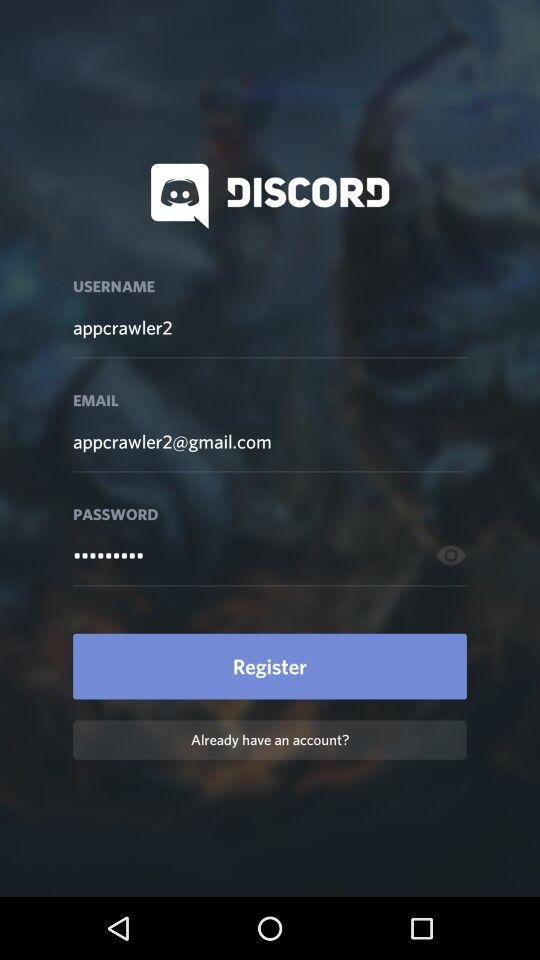What is the user name?
When the provided information is insufficient, respond with <no answer>. <no answer> 